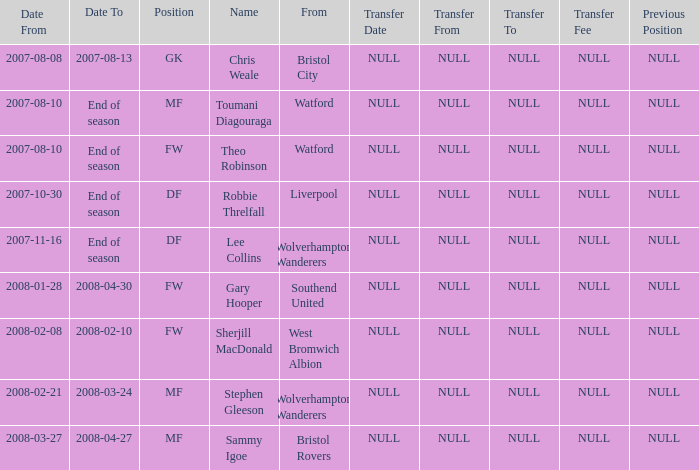From which place was the df-positioned player, who commenced on 2007-10-30, hailing? Liverpool. 